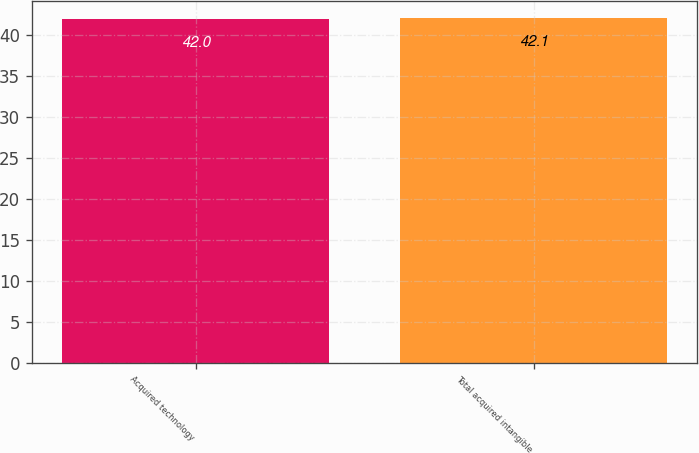Convert chart to OTSL. <chart><loc_0><loc_0><loc_500><loc_500><bar_chart><fcel>Acquired technology<fcel>Total acquired intangible<nl><fcel>42<fcel>42.1<nl></chart> 